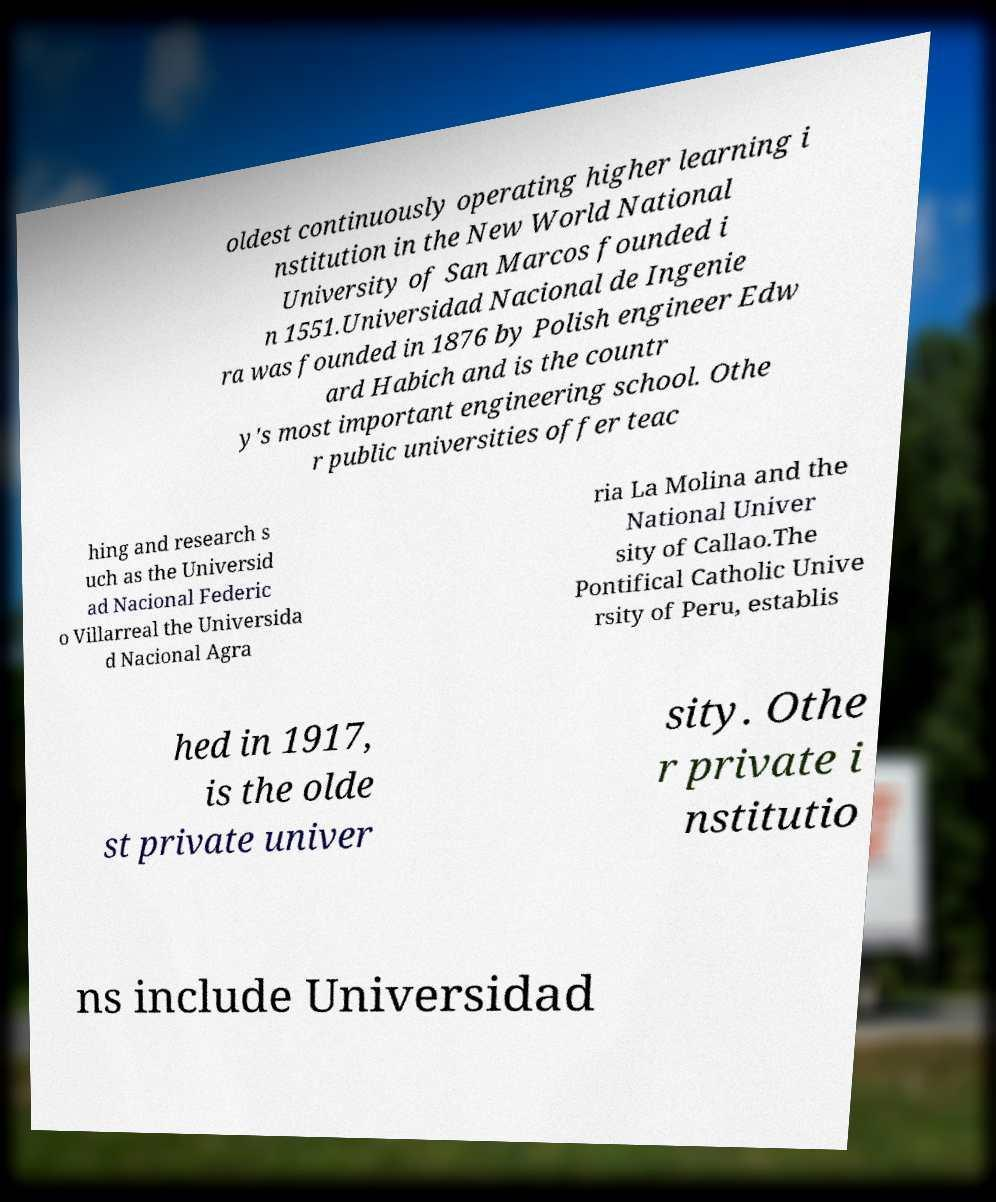Can you read and provide the text displayed in the image?This photo seems to have some interesting text. Can you extract and type it out for me? oldest continuously operating higher learning i nstitution in the New World National University of San Marcos founded i n 1551.Universidad Nacional de Ingenie ra was founded in 1876 by Polish engineer Edw ard Habich and is the countr y's most important engineering school. Othe r public universities offer teac hing and research s uch as the Universid ad Nacional Federic o Villarreal the Universida d Nacional Agra ria La Molina and the National Univer sity of Callao.The Pontifical Catholic Unive rsity of Peru, establis hed in 1917, is the olde st private univer sity. Othe r private i nstitutio ns include Universidad 